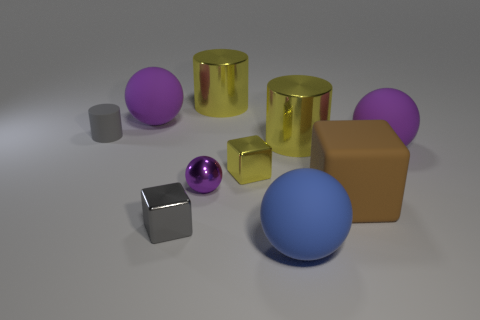Are there any shiny cylinders of the same color as the matte cube?
Your response must be concise. No. How big is the block that is on the left side of the yellow thing in front of the big shiny object in front of the gray rubber object?
Keep it short and to the point. Small. There is a purple shiny thing; is it the same shape as the tiny metal thing that is on the left side of the tiny purple metallic ball?
Provide a succinct answer. No. What number of other things are the same size as the brown cube?
Your response must be concise. 5. What size is the yellow object that is on the right side of the blue rubber sphere?
Give a very brief answer. Large. How many other tiny cylinders have the same material as the tiny gray cylinder?
Your answer should be compact. 0. There is a big purple rubber thing that is on the right side of the blue rubber ball; is its shape the same as the gray rubber thing?
Ensure brevity in your answer.  No. What shape is the large object that is in front of the big brown thing?
Provide a short and direct response. Sphere. What is the size of the shiny block that is the same color as the tiny matte object?
Provide a short and direct response. Small. What is the small purple ball made of?
Your response must be concise. Metal. 